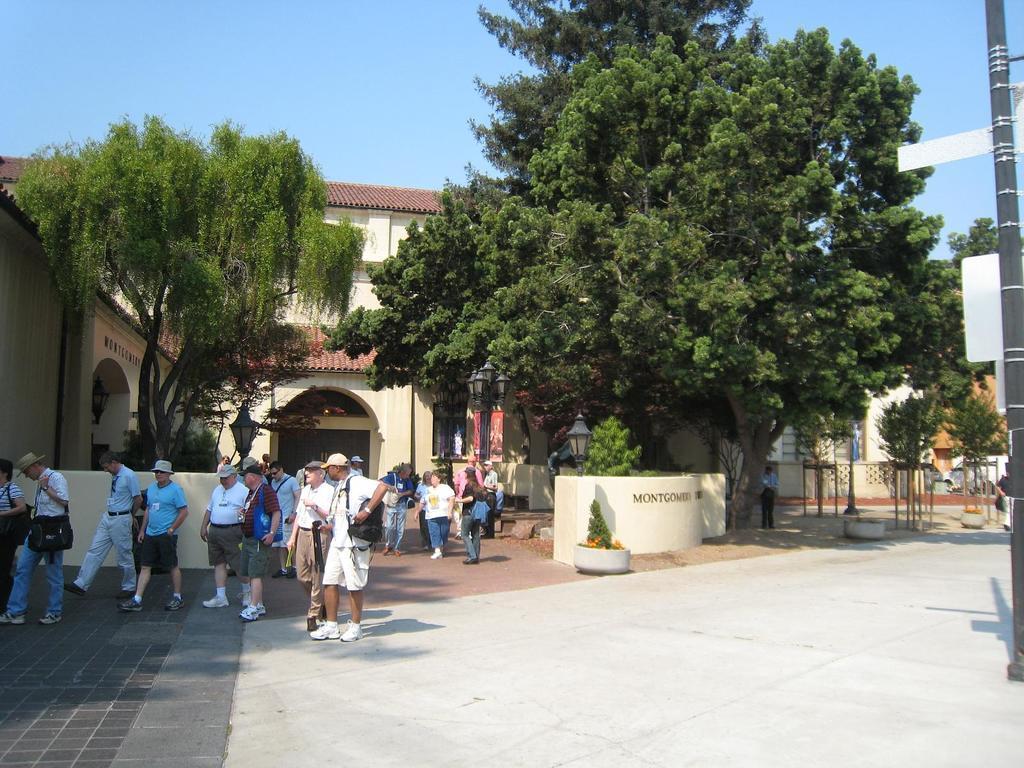Can you describe this image briefly? In this image, we can see people wearing caps and in the background, there are trees, poles, flower pots, lights and we can see some stands. At the bottom, there is a road and at the top, there is sky. 